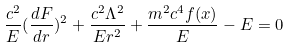<formula> <loc_0><loc_0><loc_500><loc_500>\frac { c ^ { 2 } } { E } ( \frac { d F } { d r } ) ^ { 2 } + \frac { c ^ { 2 } \Lambda ^ { 2 } } { E r ^ { 2 } } + \frac { m ^ { 2 } c ^ { 4 } f ( x ) } { E } - E = 0</formula> 